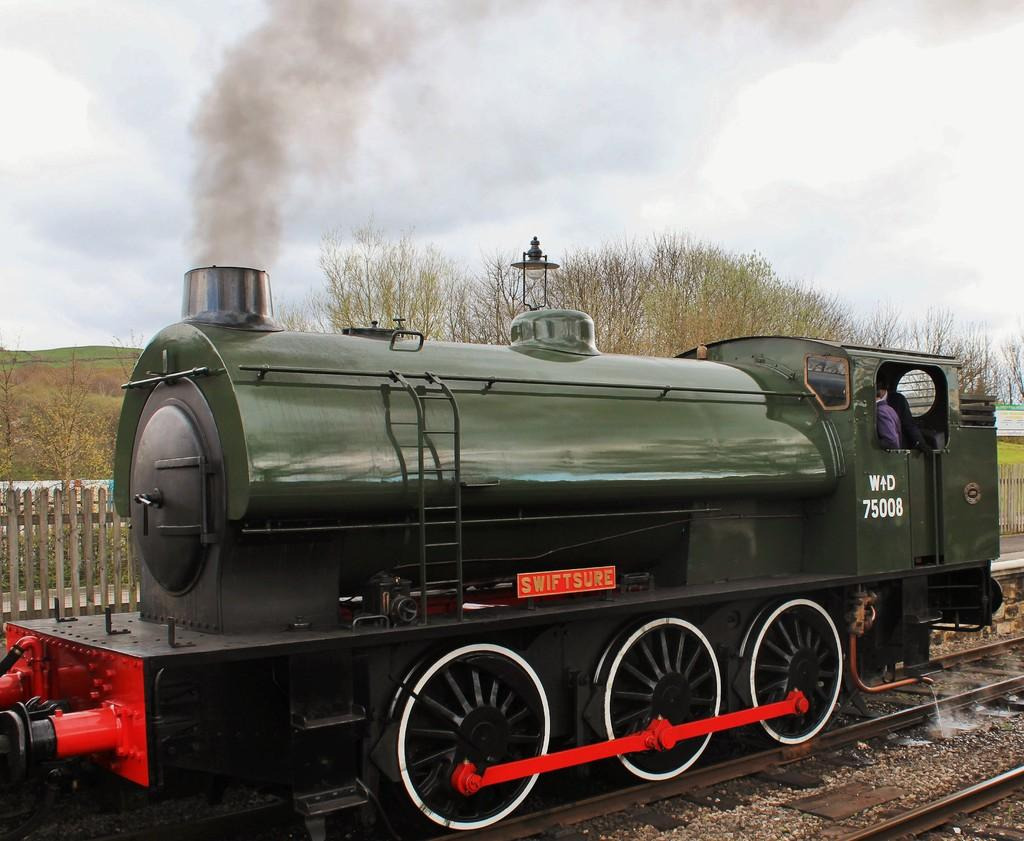What is the main subject of the image? The main subject of the image is a train. Can you describe the train's position in the image? The train is on a track. Is there anyone inside the train? Yes, there is a person inside the train. What can be seen in the background of the image? There are trees and a fence in the background of the image. What rule is being taught by the person inside the train in the image? There is no indication in the image that the person inside the train is teaching any rules. 